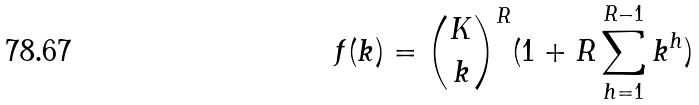<formula> <loc_0><loc_0><loc_500><loc_500>f ( k ) = \binom { K } { k } ^ { R } ( 1 + R \sum _ { h = 1 } ^ { R - 1 } k ^ { h } )</formula> 